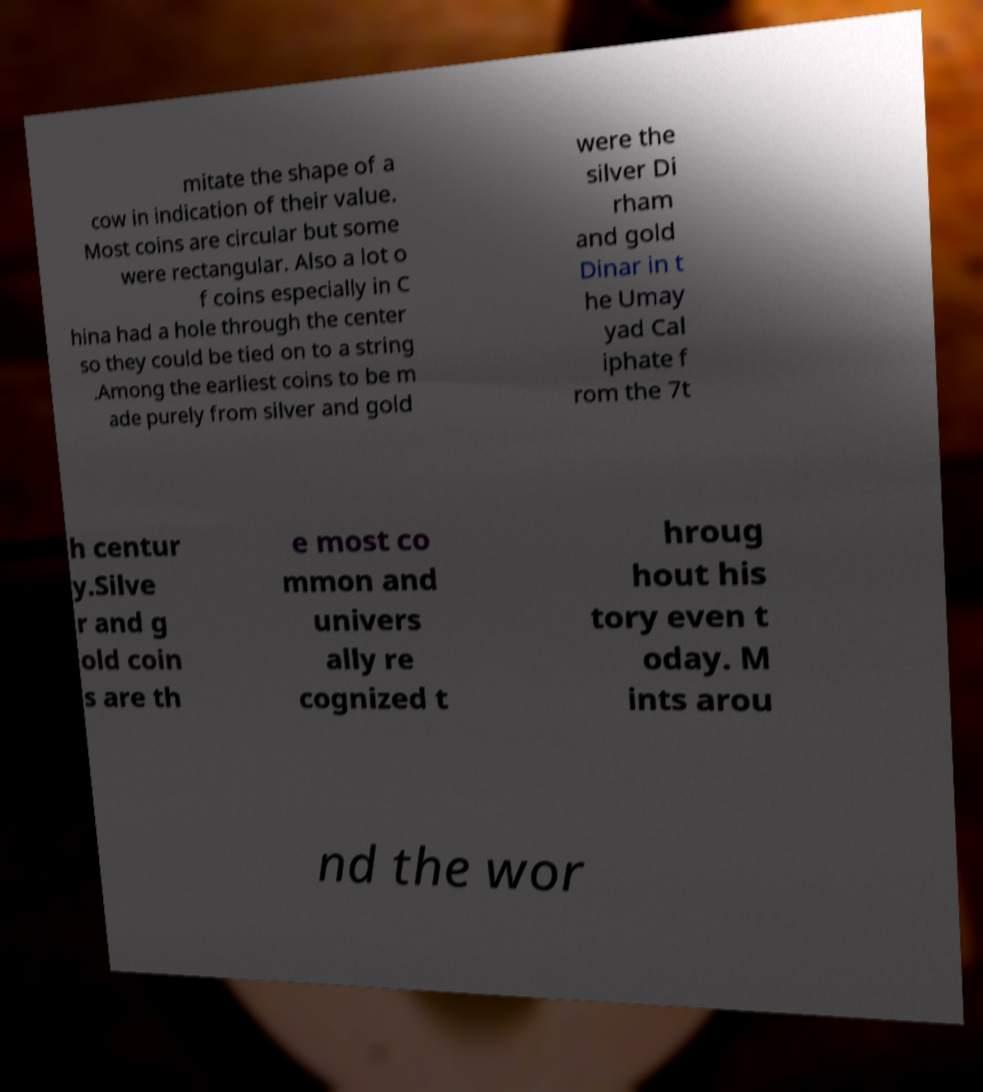Please read and relay the text visible in this image. What does it say? mitate the shape of a cow in indication of their value. Most coins are circular but some were rectangular. Also a lot o f coins especially in C hina had a hole through the center so they could be tied on to a string .Among the earliest coins to be m ade purely from silver and gold were the silver Di rham and gold Dinar in t he Umay yad Cal iphate f rom the 7t h centur y.Silve r and g old coin s are th e most co mmon and univers ally re cognized t hroug hout his tory even t oday. M ints arou nd the wor 